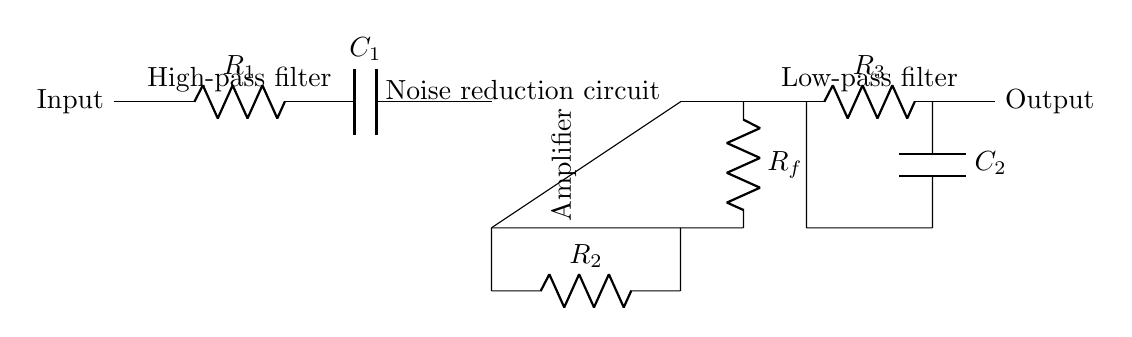What is the main function of this circuit? The circuit is designed to reduce noise in sensitive audio recordings, ensuring clearer audio. It employs a combination of filtering and amplification to enhance signal quality.
Answer: Noise reduction What type of filter is implemented at the input? The input part of the circuit has a high-pass filter made up of a resistor and capacitor which allows signals above a certain frequency to pass while attenuating lower frequencies.
Answer: High-pass filter What component type is used for amplification in this circuit? The amplification is done by an operational amplifier, which is indicated in the diagram as the section labeled “Amplifier.” It boosts the input voltage for further processing.
Answer: Operational amplifier What is the role of the feedback resistor in the circuit? The feedback resistor is a key component in the operational amplifier section, controlling the gain of the amplifier and helping stabilize the output signal relative to the input.
Answer: Gain control What type of filter is used at the output of the circuit? The output is processed through a low-pass filter, which allows low-frequency signals to pass while attenuating higher frequencies, effectively smoothing the sound.
Answer: Low-pass filter How many resistors are used in the circuit? There are three resistors in total as visible from the diagram, denoted by R1, R2, and R3, which serve in the filtering and amplification processes.
Answer: Three resistors What does the symbol in the middle section of the circuit diagram represent? The middle section represents an operational amplifier, which is drawn in a standard form with input and output terminals, allowing it to amplify the audio signal.
Answer: Operational amplifier 